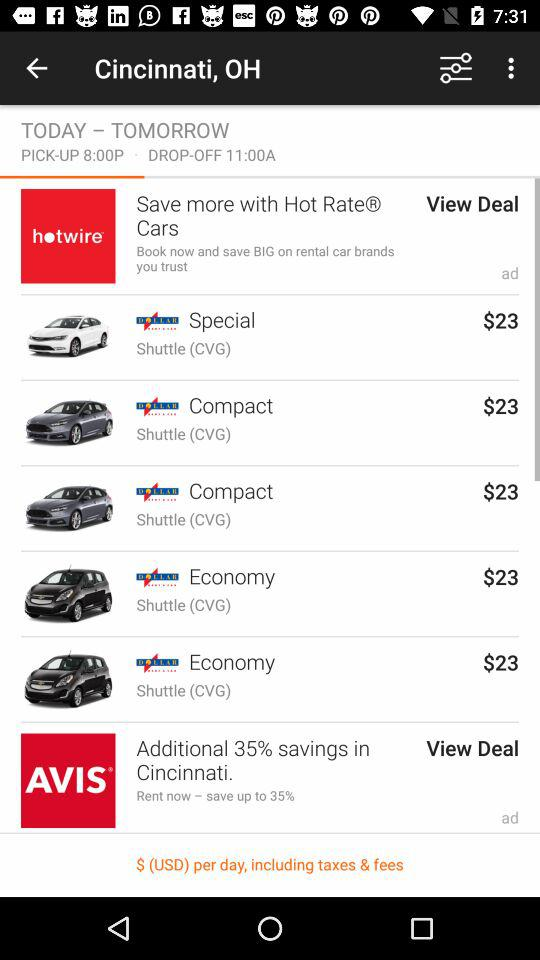What is the fare for the special class? The fare for the special class is $23. 